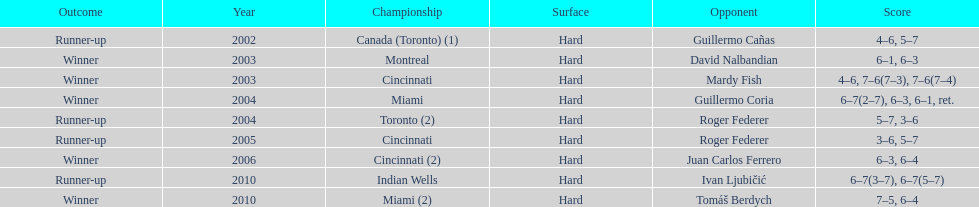How often did roddick play against opponents who were not from the united states? 8. 